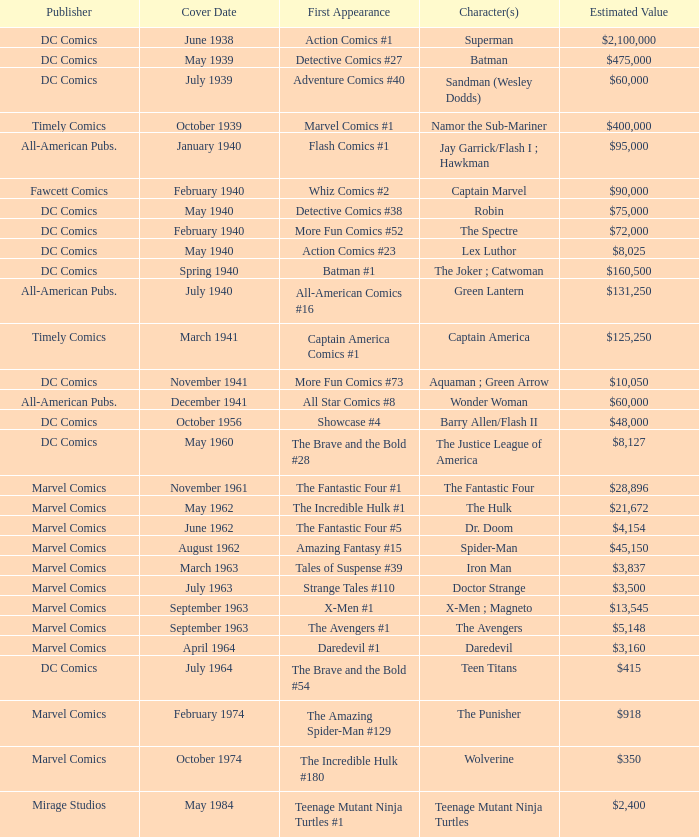What is Action Comics #1's estimated value? $2,100,000. Write the full table. {'header': ['Publisher', 'Cover Date', 'First Appearance', 'Character(s)', 'Estimated Value'], 'rows': [['DC Comics', 'June 1938', 'Action Comics #1', 'Superman', '$2,100,000'], ['DC Comics', 'May 1939', 'Detective Comics #27', 'Batman', '$475,000'], ['DC Comics', 'July 1939', 'Adventure Comics #40', 'Sandman (Wesley Dodds)', '$60,000'], ['Timely Comics', 'October 1939', 'Marvel Comics #1', 'Namor the Sub-Mariner', '$400,000'], ['All-American Pubs.', 'January 1940', 'Flash Comics #1', 'Jay Garrick/Flash I ; Hawkman', '$95,000'], ['Fawcett Comics', 'February 1940', 'Whiz Comics #2', 'Captain Marvel', '$90,000'], ['DC Comics', 'May 1940', 'Detective Comics #38', 'Robin', '$75,000'], ['DC Comics', 'February 1940', 'More Fun Comics #52', 'The Spectre', '$72,000'], ['DC Comics', 'May 1940', 'Action Comics #23', 'Lex Luthor', '$8,025'], ['DC Comics', 'Spring 1940', 'Batman #1', 'The Joker ; Catwoman', '$160,500'], ['All-American Pubs.', 'July 1940', 'All-American Comics #16', 'Green Lantern', '$131,250'], ['Timely Comics', 'March 1941', 'Captain America Comics #1', 'Captain America', '$125,250'], ['DC Comics', 'November 1941', 'More Fun Comics #73', 'Aquaman ; Green Arrow', '$10,050'], ['All-American Pubs.', 'December 1941', 'All Star Comics #8', 'Wonder Woman', '$60,000'], ['DC Comics', 'October 1956', 'Showcase #4', 'Barry Allen/Flash II', '$48,000'], ['DC Comics', 'May 1960', 'The Brave and the Bold #28', 'The Justice League of America', '$8,127'], ['Marvel Comics', 'November 1961', 'The Fantastic Four #1', 'The Fantastic Four', '$28,896'], ['Marvel Comics', 'May 1962', 'The Incredible Hulk #1', 'The Hulk', '$21,672'], ['Marvel Comics', 'June 1962', 'The Fantastic Four #5', 'Dr. Doom', '$4,154'], ['Marvel Comics', 'August 1962', 'Amazing Fantasy #15', 'Spider-Man', '$45,150'], ['Marvel Comics', 'March 1963', 'Tales of Suspense #39', 'Iron Man', '$3,837'], ['Marvel Comics', 'July 1963', 'Strange Tales #110', 'Doctor Strange', '$3,500'], ['Marvel Comics', 'September 1963', 'X-Men #1', 'X-Men ; Magneto', '$13,545'], ['Marvel Comics', 'September 1963', 'The Avengers #1', 'The Avengers', '$5,148'], ['Marvel Comics', 'April 1964', 'Daredevil #1', 'Daredevil', '$3,160'], ['DC Comics', 'July 1964', 'The Brave and the Bold #54', 'Teen Titans', '$415'], ['Marvel Comics', 'February 1974', 'The Amazing Spider-Man #129', 'The Punisher', '$918'], ['Marvel Comics', 'October 1974', 'The Incredible Hulk #180', 'Wolverine', '$350'], ['Mirage Studios', 'May 1984', 'Teenage Mutant Ninja Turtles #1', 'Teenage Mutant Ninja Turtles', '$2,400']]} 